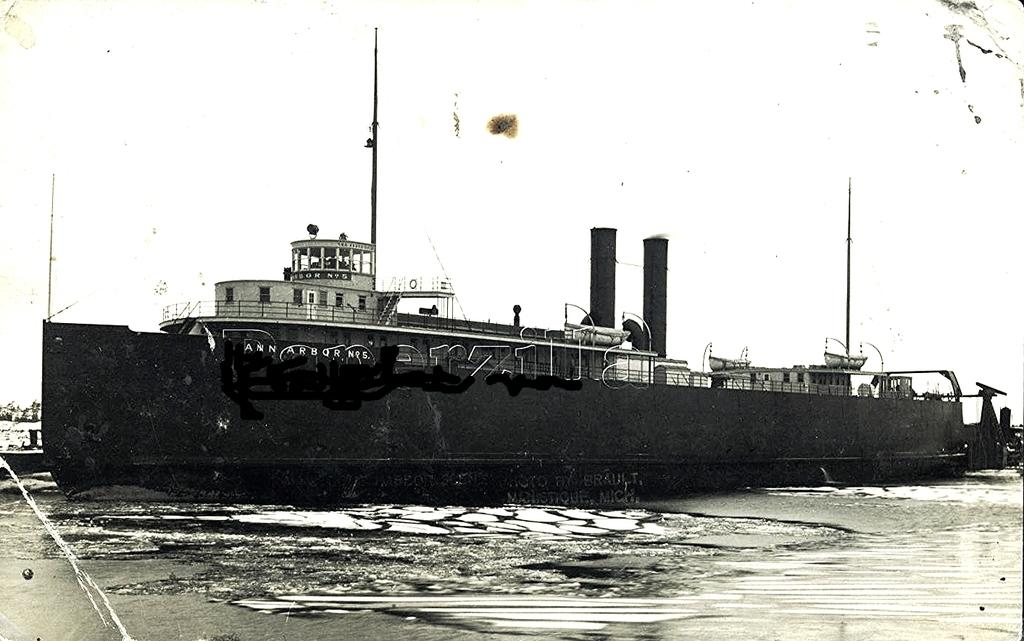What is the main subject in the middle of the image? There is a ship in the middle of the image. What is located at the bottom of the image? There is water at the bottom of the image. What can be seen in the background of the image? The background of the image is the sky. What type of button is being used to steer the ship in the image? There is no button present in the image, and buttons are not used to steer ships. 